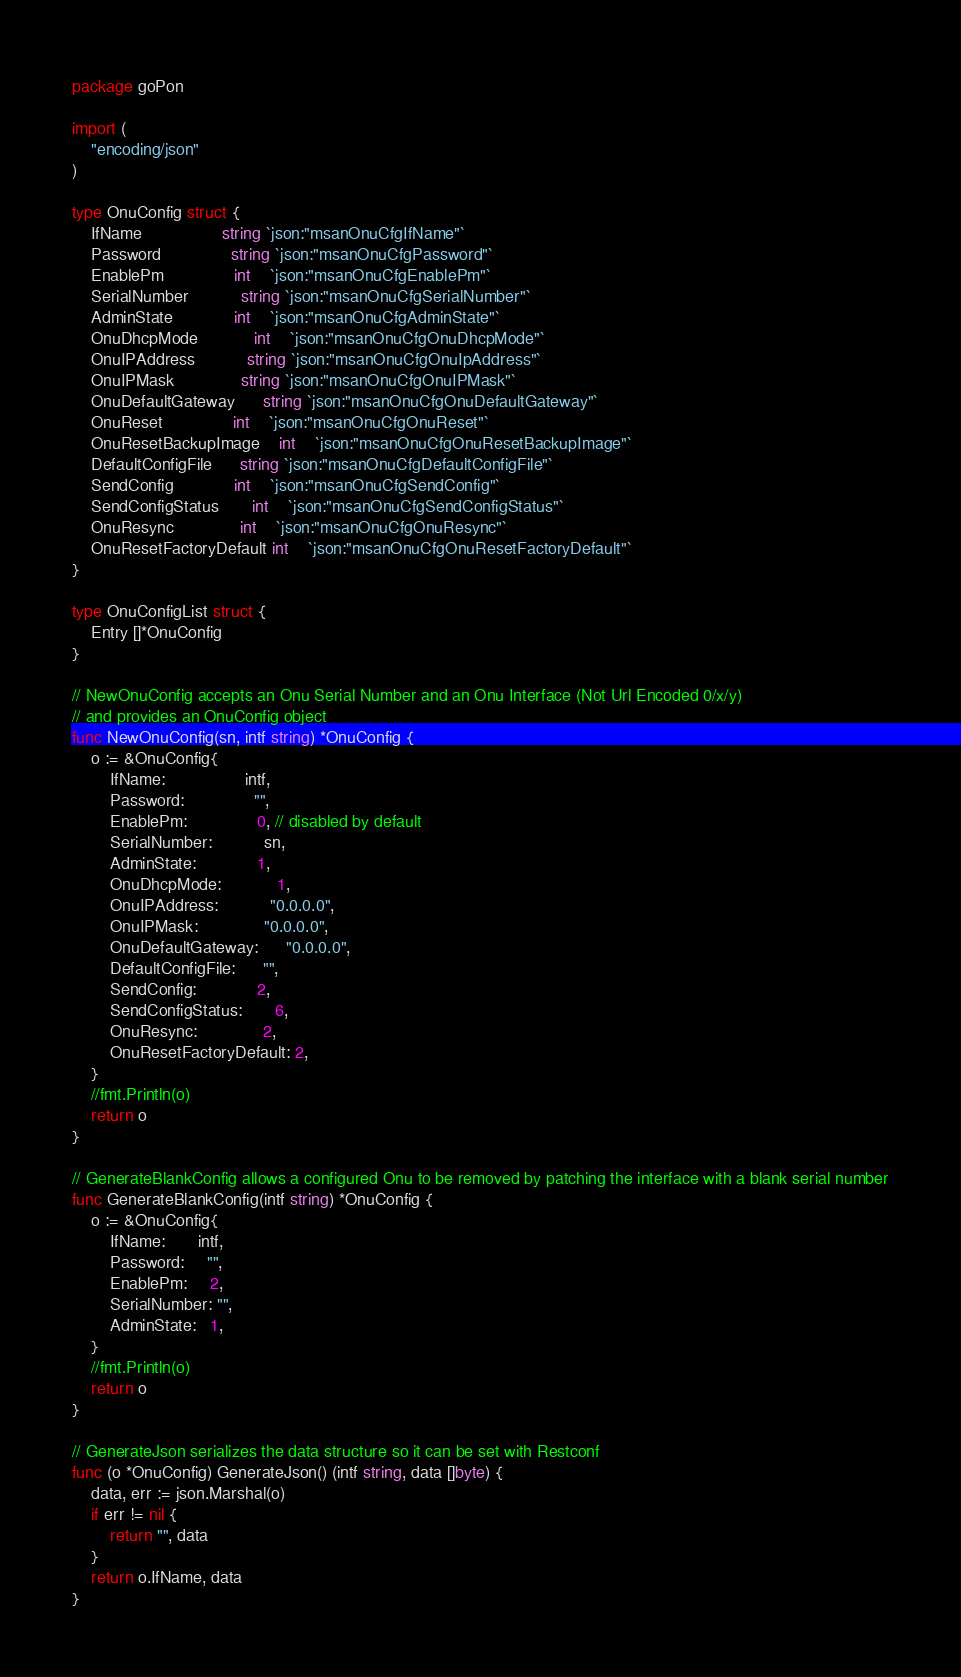<code> <loc_0><loc_0><loc_500><loc_500><_Go_>package goPon

import (
	"encoding/json"
)

type OnuConfig struct {
	IfName                 string `json:"msanOnuCfgIfName"`
	Password               string `json:"msanOnuCfgPassword"`
	EnablePm               int    `json:"msanOnuCfgEnablePm"`
	SerialNumber           string `json:"msanOnuCfgSerialNumber"`
	AdminState             int    `json:"msanOnuCfgAdminState"`
	OnuDhcpMode            int    `json:"msanOnuCfgOnuDhcpMode"`
	OnuIPAddress           string `json:"msanOnuCfgOnuIpAddress"`
	OnuIPMask              string `json:"msanOnuCfgOnuIPMask"`
	OnuDefaultGateway      string `json:"msanOnuCfgOnuDefaultGateway"`
	OnuReset               int    `json:"msanOnuCfgOnuReset"`
	OnuResetBackupImage    int    `json:"msanOnuCfgOnuResetBackupImage"`
	DefaultConfigFile      string `json:"msanOnuCfgDefaultConfigFile"`
	SendConfig             int    `json:"msanOnuCfgSendConfig"`
	SendConfigStatus       int    `json:"msanOnuCfgSendConfigStatus"`
	OnuResync              int    `json:"msanOnuCfgOnuResync"`
	OnuResetFactoryDefault int    `json:"msanOnuCfgOnuResetFactoryDefault"`
}

type OnuConfigList struct {
	Entry []*OnuConfig
}

// NewOnuConfig accepts an Onu Serial Number and an Onu Interface (Not Url Encoded 0/x/y)
// and provides an OnuConfig object
func NewOnuConfig(sn, intf string) *OnuConfig {
	o := &OnuConfig{
		IfName:                 intf,
		Password:               "",
		EnablePm:               0, // disabled by default
		SerialNumber:           sn,
		AdminState:             1,
		OnuDhcpMode:            1,
		OnuIPAddress:           "0.0.0.0",
		OnuIPMask:              "0.0.0.0",
		OnuDefaultGateway:      "0.0.0.0",
		DefaultConfigFile:      "",
		SendConfig:             2,
		SendConfigStatus:       6,
		OnuResync:              2,
		OnuResetFactoryDefault: 2,
	}
	//fmt.Println(o)
	return o
}

// GenerateBlankConfig allows a configured Onu to be removed by patching the interface with a blank serial number
func GenerateBlankConfig(intf string) *OnuConfig {
	o := &OnuConfig{
		IfName:       intf,
		Password:     "",
		EnablePm:     2,
		SerialNumber: "",
		AdminState:   1,
	}
	//fmt.Println(o)
	return o
}

// GenerateJson serializes the data structure so it can be set with Restconf
func (o *OnuConfig) GenerateJson() (intf string, data []byte) {
	data, err := json.Marshal(o)
	if err != nil {
		return "", data
	}
	return o.IfName, data
}
</code> 